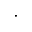Convert formula to latex. <formula><loc_0><loc_0><loc_500><loc_500>\cdot</formula> 